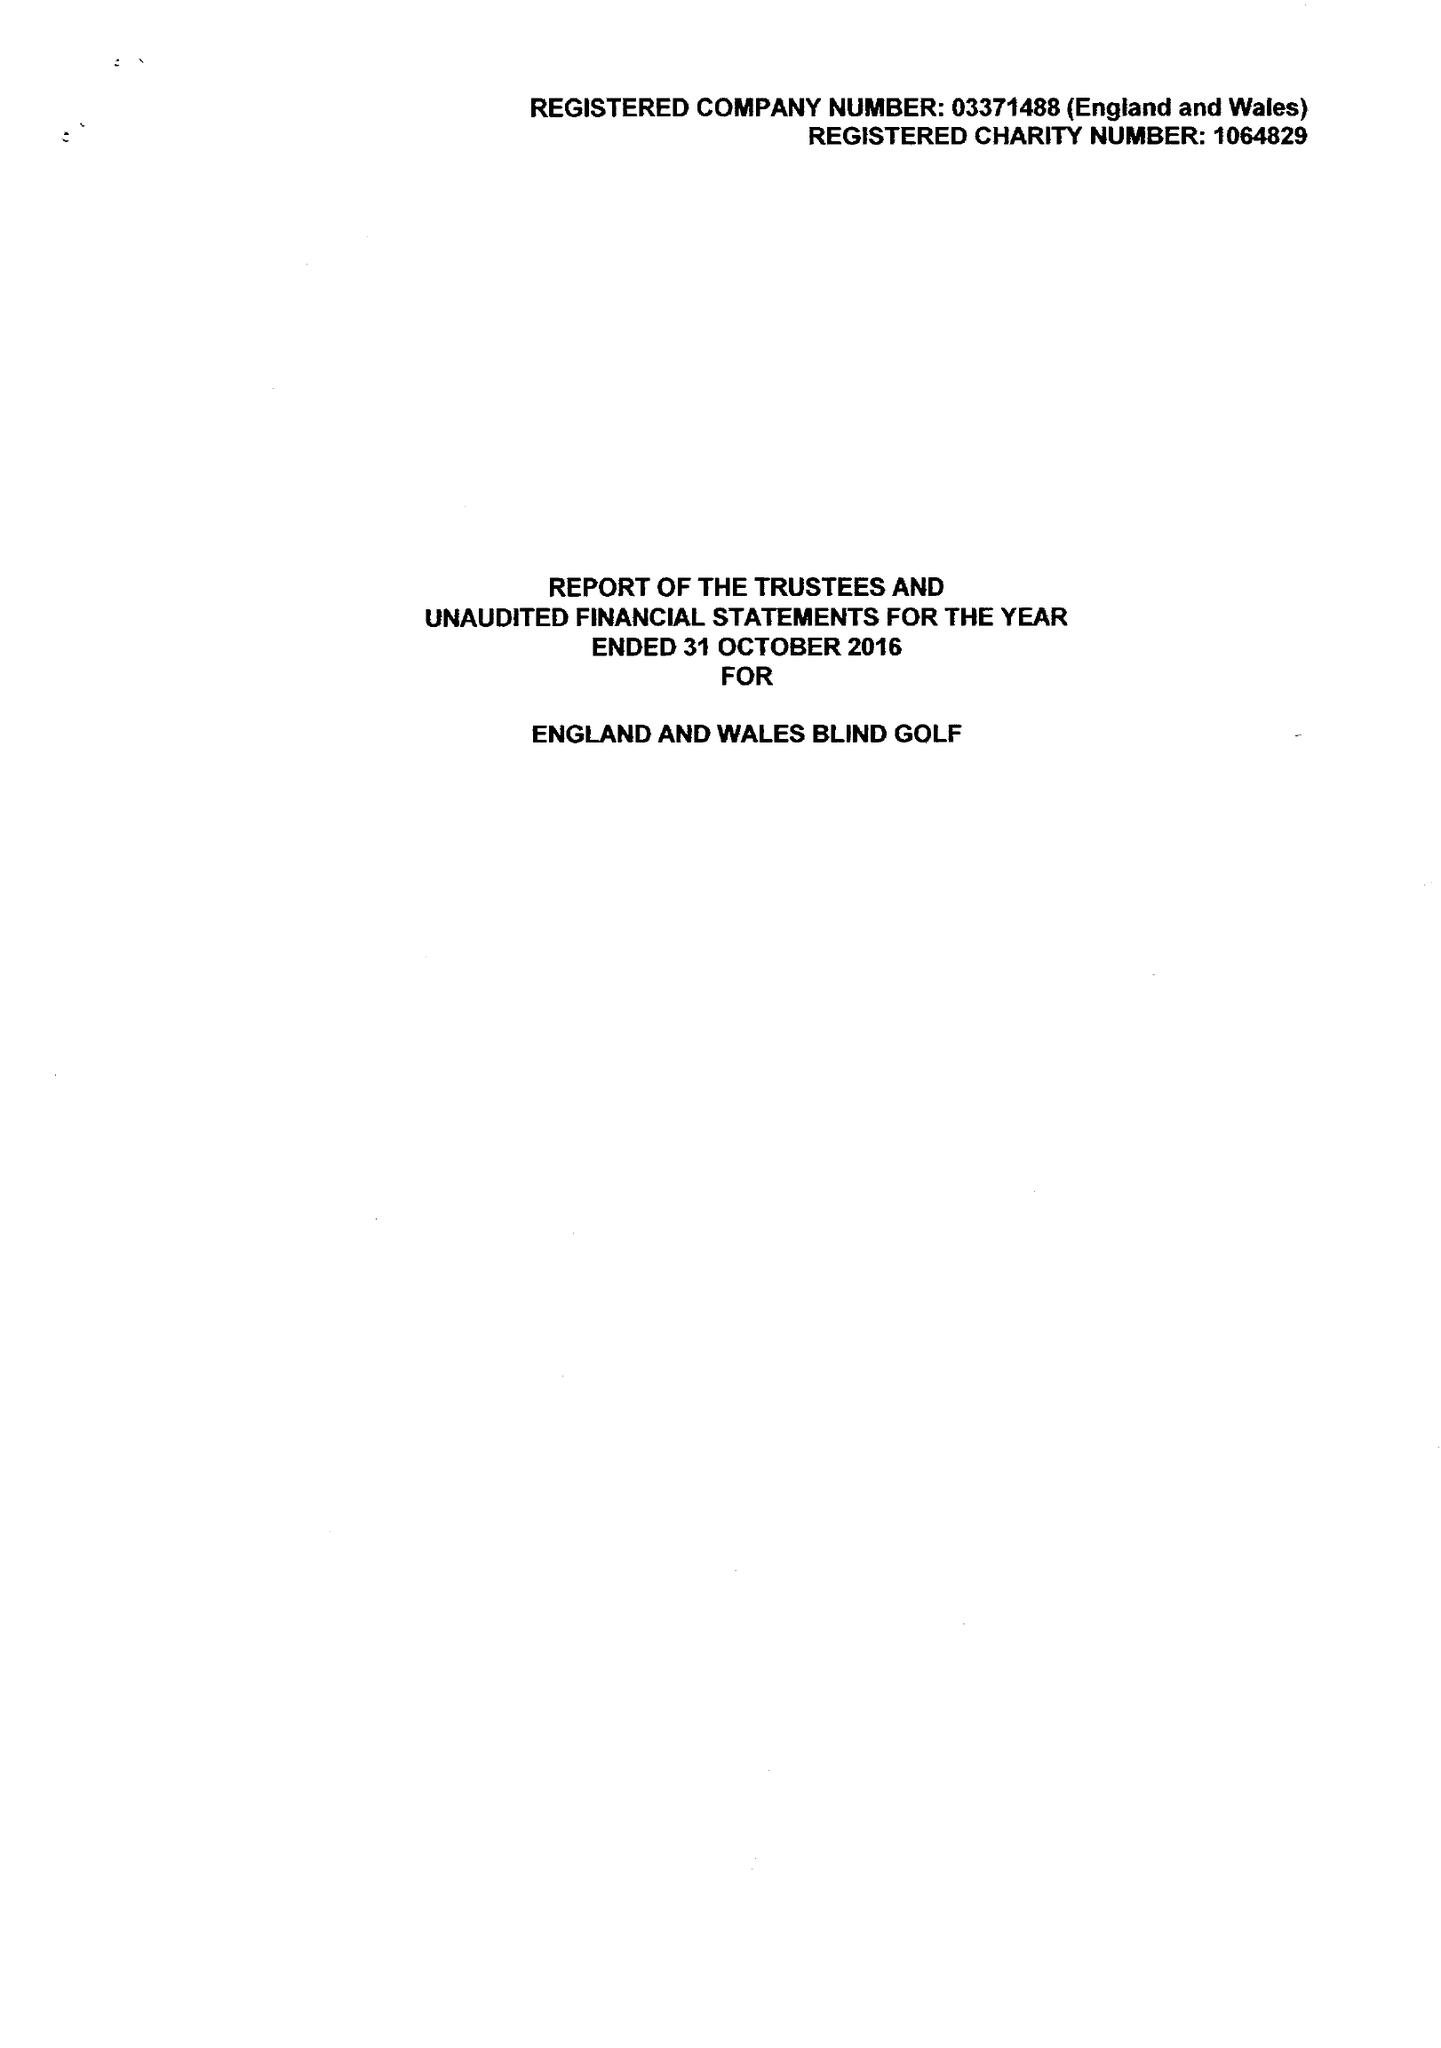What is the value for the address__postcode?
Answer the question using a single word or phrase. PO9 1QU 